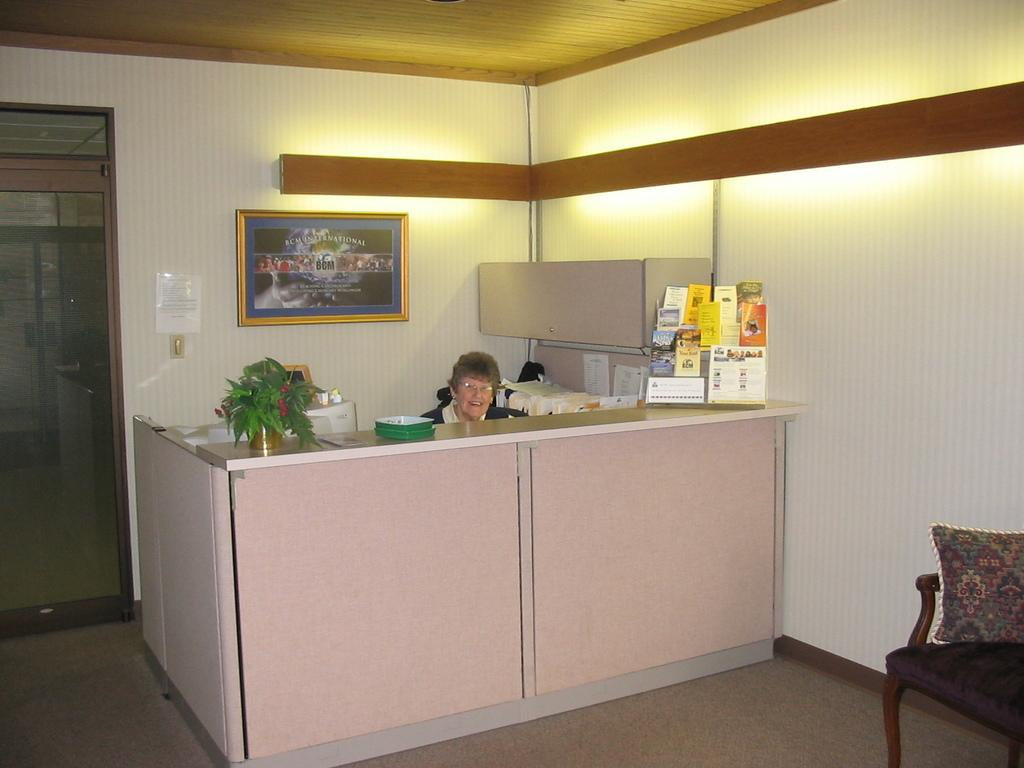What is the woman in the image doing? The woman is sitting in a chair in the image. What objects can be seen on the table in the image? There are books on the table in the image. What type of furniture is present in the image besides the chair and table? There is a couch and a plant in the image. What is attached to the wall in the image? There is a frame attached to the wall in the image. What is the purpose of the door in the image? The door in the image provides access to another room or area. What is placed on the couch in the image? There is a pillow on the couch in the image. What is the price of the root vegetable on the table in the image? There is no root vegetable present in the image; only books are on the table. 